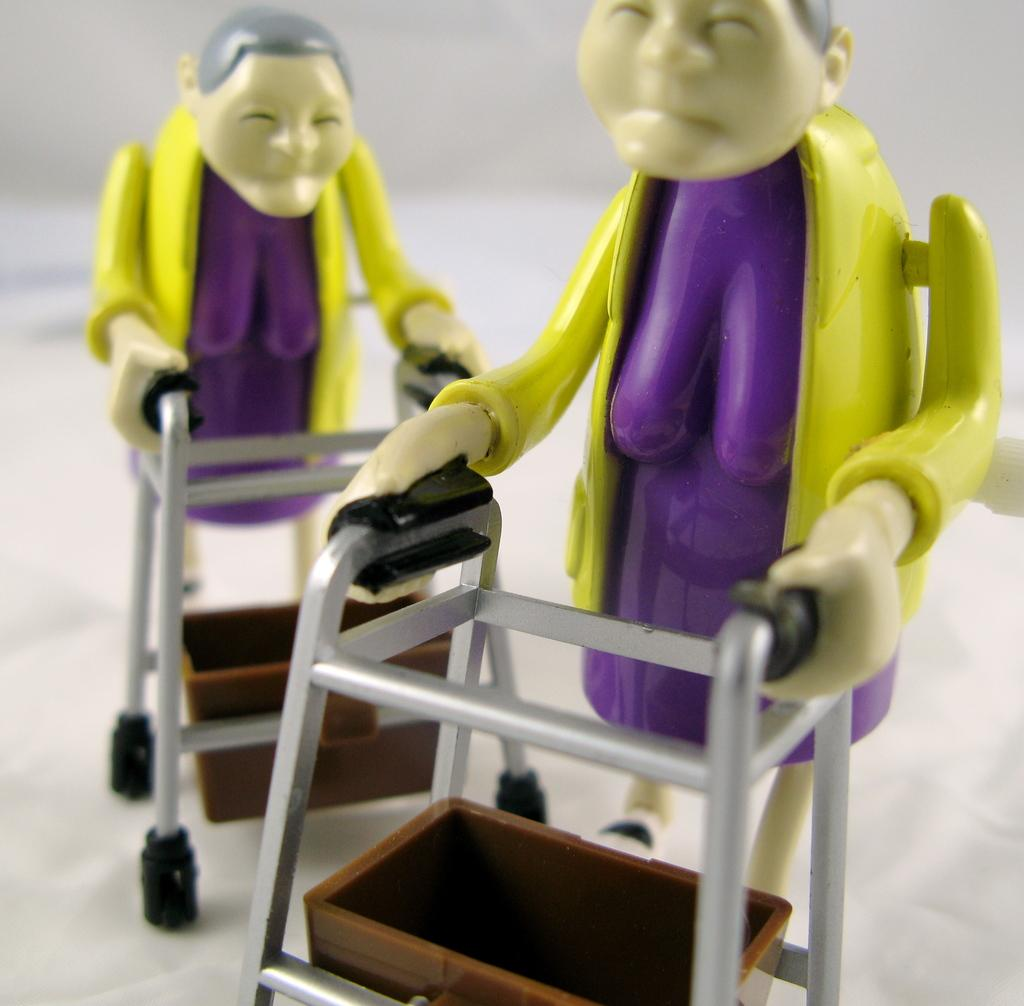What type of toys are in the image? There are two women toys in the image. How are the toys positioned in the image? The toys are holding supporting stands. Where are the toys located in the image? The toys are on a platform. What type of glue is being used to keep the toys together in the image? There is no glue present in the image, and the toys are not attached to each other. Is there a prison visible in the image? There is no prison present in the image. 